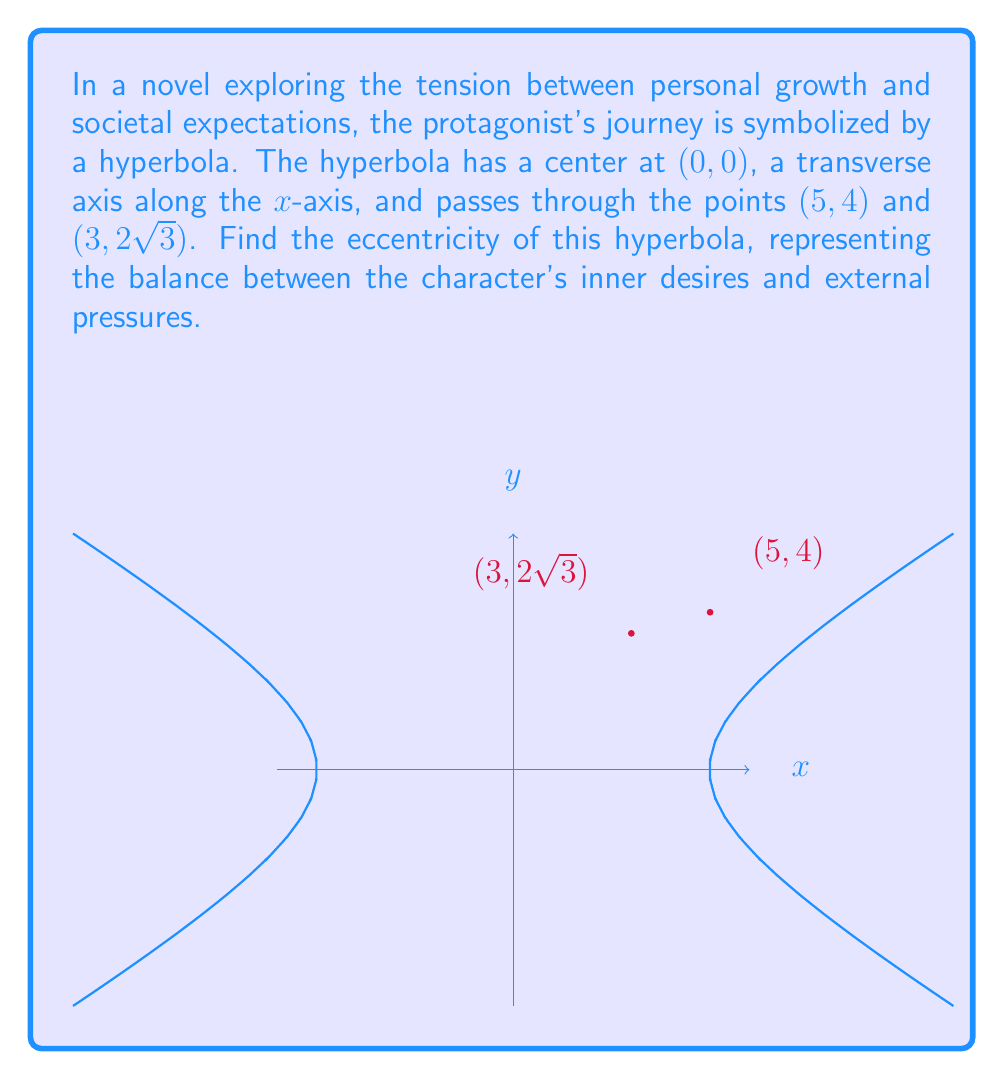Could you help me with this problem? Let's approach this step-by-step:

1) The general equation of a hyperbola with center (0, 0) and transverse axis along the x-axis is:

   $$\frac{x^2}{a^2} - \frac{y^2}{b^2} = 1$$

   where $a$ is the distance from the center to the vertex, and $b$ is the length of the conjugate axis.

2) We know the hyperbola passes through (5, 4) and (3, 2√3). Let's use the point (5, 4) first:

   $$\frac{5^2}{a^2} - \frac{4^2}{b^2} = 1$$

3) Now, let's use the point (3, 2√3):

   $$\frac{3^2}{a^2} - \frac{(2\sqrt{3})^2}{b^2} = 1$$

4) Simplify the second equation:

   $$\frac{9}{a^2} - \frac{12}{b^2} = 1$$

5) We now have two equations:

   $$\frac{25}{a^2} - \frac{16}{b^2} = 1$$
   $$\frac{9}{a^2} - \frac{12}{b^2} = 1$$

6) Subtract the second equation from the first:

   $$\frac{16}{a^2} - \frac{4}{b^2} = 0$$

7) Simplify:

   $$\frac{4}{a^2} = \frac{1}{b^2}$$

8) This means:

   $$b^2 = \frac{a^2}{4}$$

9) Substitute this back into one of our original equations, say the first one:

   $$\frac{25}{a^2} - \frac{16}{\frac{a^2}{4}} = 1$$

10) Simplify:

    $$\frac{25}{a^2} - \frac{64}{a^2} = 1$$
    $$\frac{-39}{a^2} = 1$$
    $$a^2 = 39$$
    $$a = \sqrt{39}$$

11) Now we can find $b$:

    $$b^2 = \frac{39}{4}$$
    $$b = \frac{\sqrt{39}}{2}$$

12) The eccentricity of a hyperbola is given by:

    $$e = \sqrt{1 + \frac{b^2}{a^2}}$$

13) Substitute our values:

    $$e = \sqrt{1 + \frac{(\frac{\sqrt{39}}{2})^2}{39}}$$

14) Simplify:

    $$e = \sqrt{1 + \frac{39/4}{39}} = \sqrt{1 + \frac{1}{4}} = \sqrt{\frac{5}{4}} = \frac{\sqrt{5}}{2}$$

Thus, the eccentricity of the hyperbola is $\frac{\sqrt{5}}{2}$.
Answer: $\frac{\sqrt{5}}{2}$ 